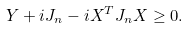Convert formula to latex. <formula><loc_0><loc_0><loc_500><loc_500>Y + i J _ { n } - i X ^ { T } J _ { n } X \geq 0 .</formula> 